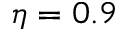Convert formula to latex. <formula><loc_0><loc_0><loc_500><loc_500>\eta = 0 . 9</formula> 